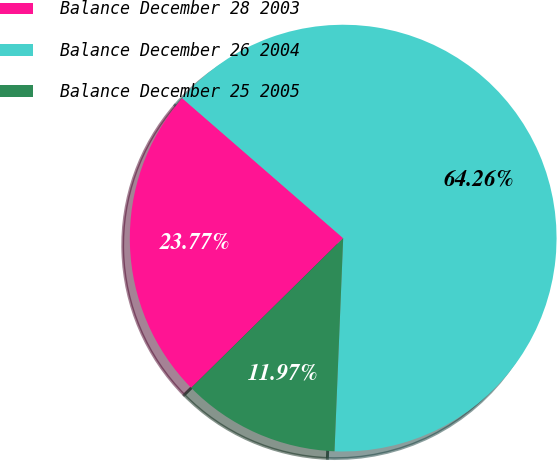Convert chart. <chart><loc_0><loc_0><loc_500><loc_500><pie_chart><fcel>Balance December 28 2003<fcel>Balance December 26 2004<fcel>Balance December 25 2005<nl><fcel>23.77%<fcel>64.26%<fcel>11.97%<nl></chart> 